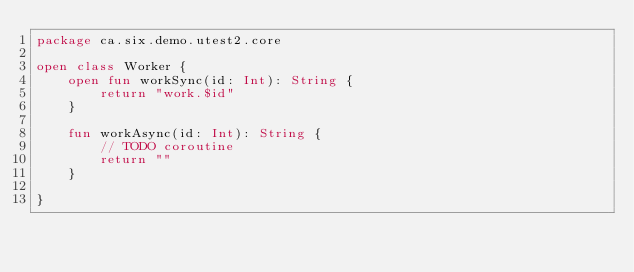Convert code to text. <code><loc_0><loc_0><loc_500><loc_500><_Kotlin_>package ca.six.demo.utest2.core

open class Worker {
    open fun workSync(id: Int): String {
        return "work.$id"
    }

    fun workAsync(id: Int): String {
        // TODO coroutine
        return ""
    }

}</code> 